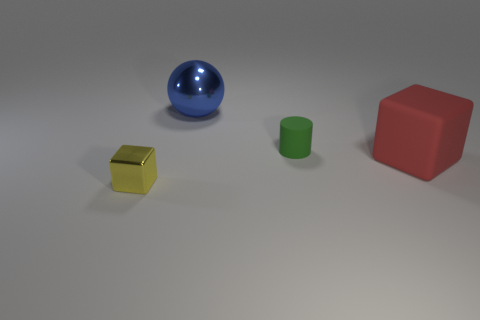Add 2 big yellow cylinders. How many objects exist? 6 Subtract all balls. How many objects are left? 3 Add 4 cyan cylinders. How many cyan cylinders exist? 4 Subtract 0 green balls. How many objects are left? 4 Subtract all large red rubber objects. Subtract all green cylinders. How many objects are left? 2 Add 4 green cylinders. How many green cylinders are left? 5 